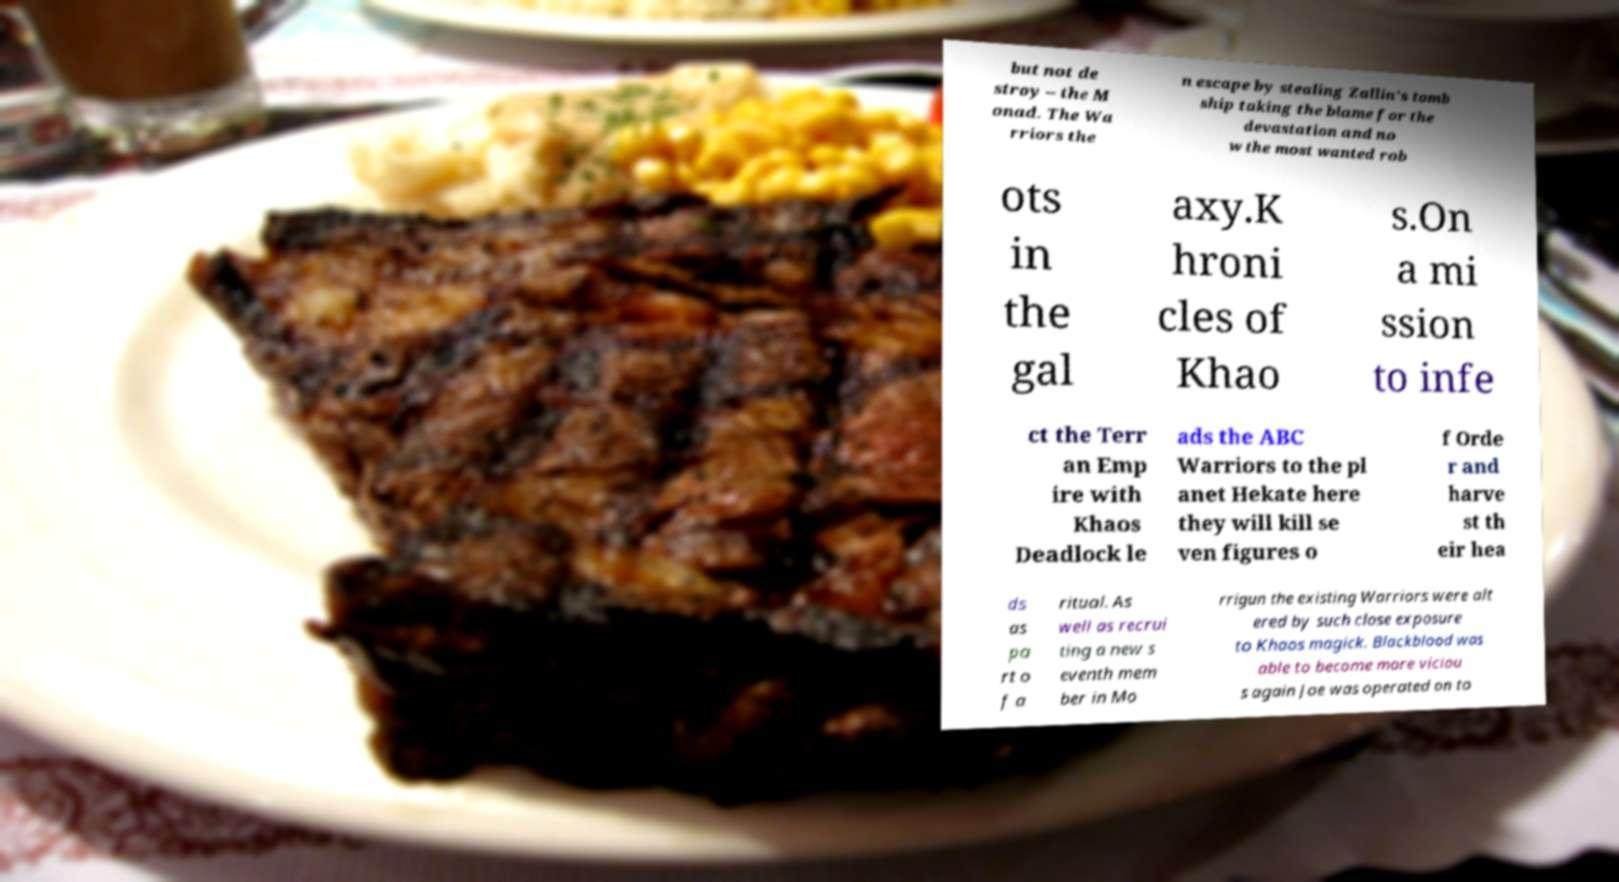Can you accurately transcribe the text from the provided image for me? but not de stroy – the M onad. The Wa rriors the n escape by stealing Zallin's tomb ship taking the blame for the devastation and no w the most wanted rob ots in the gal axy.K hroni cles of Khao s.On a mi ssion to infe ct the Terr an Emp ire with Khaos Deadlock le ads the ABC Warriors to the pl anet Hekate here they will kill se ven figures o f Orde r and harve st th eir hea ds as pa rt o f a ritual. As well as recrui ting a new s eventh mem ber in Mo rrigun the existing Warriors were alt ered by such close exposure to Khaos magick. Blackblood was able to become more viciou s again Joe was operated on to 